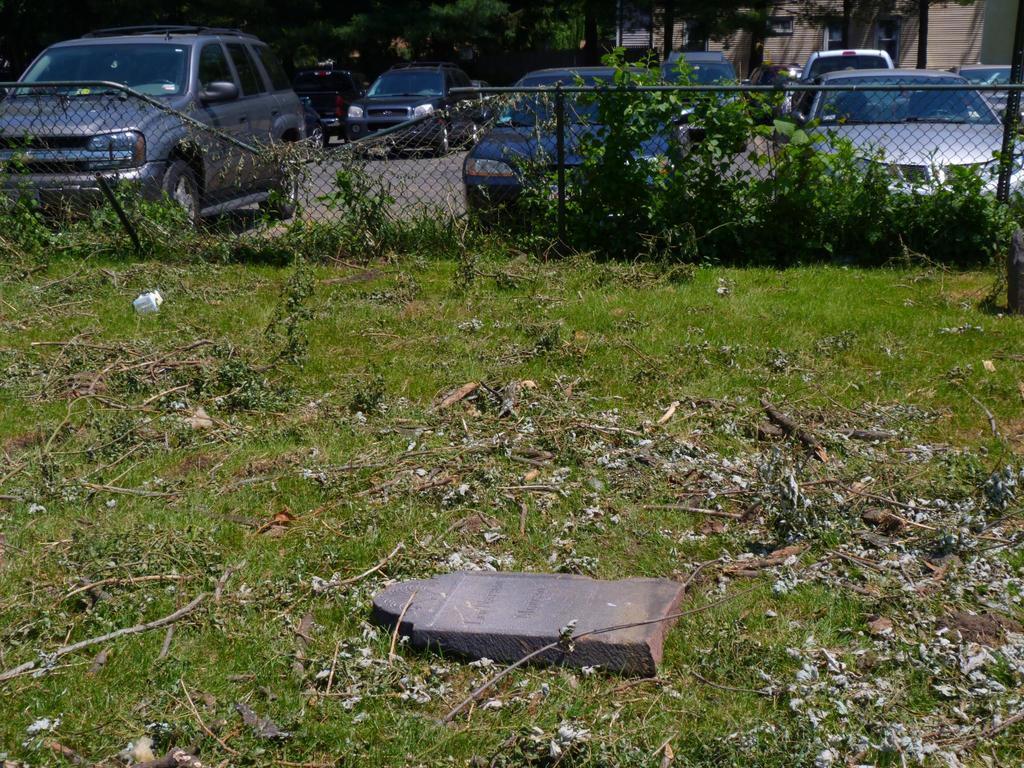Could you give a brief overview of what you see in this image? Here on the ground we can see grass and dust and there are plants at the fence. In the background there are vehicles on the road,trees,windows and a building. 